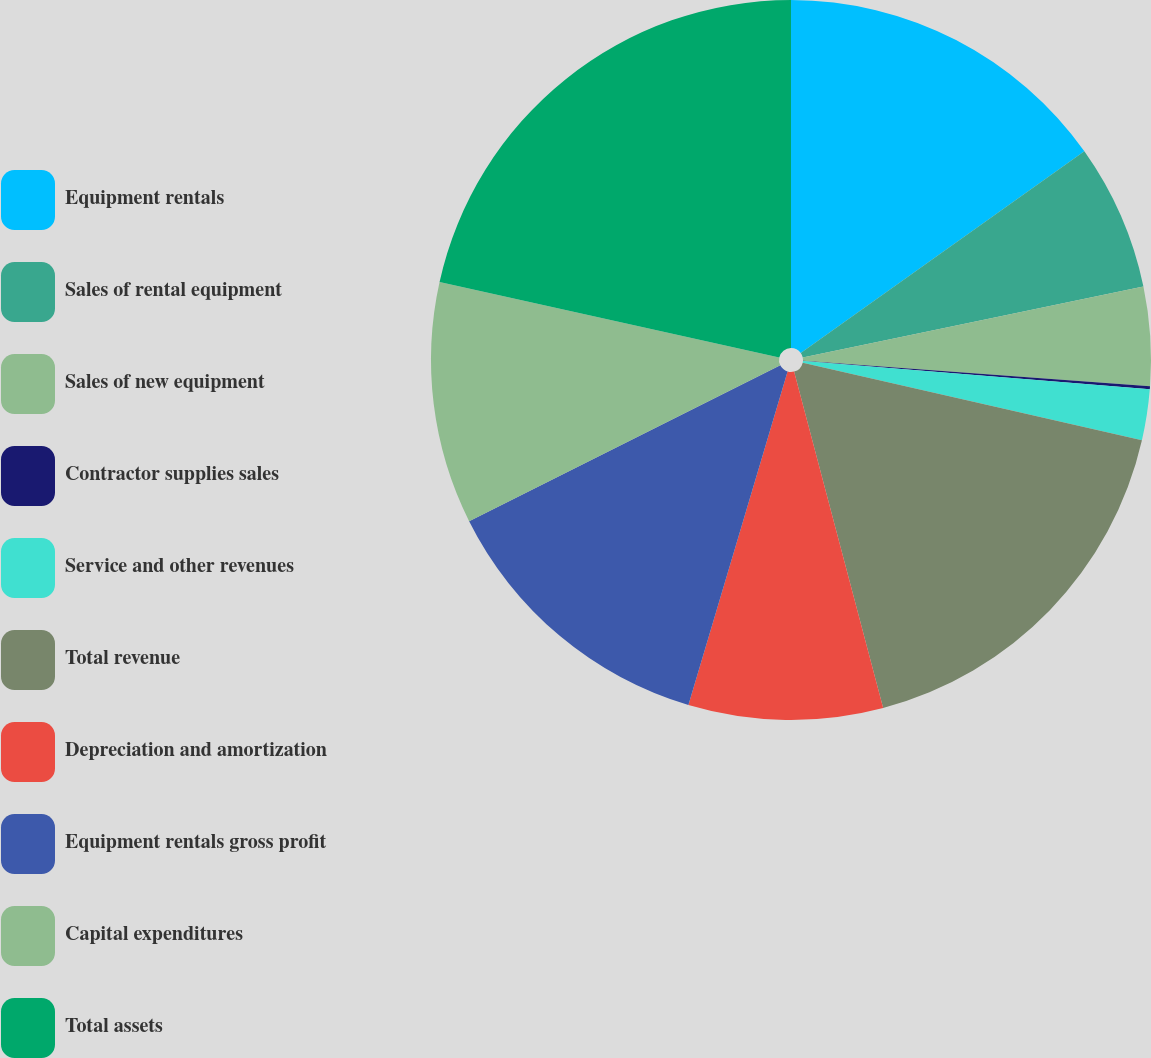Convert chart to OTSL. <chart><loc_0><loc_0><loc_500><loc_500><pie_chart><fcel>Equipment rentals<fcel>Sales of rental equipment<fcel>Sales of new equipment<fcel>Contractor supplies sales<fcel>Service and other revenues<fcel>Total revenue<fcel>Depreciation and amortization<fcel>Equipment rentals gross profit<fcel>Capital expenditures<fcel>Total assets<nl><fcel>15.16%<fcel>6.57%<fcel>4.43%<fcel>0.14%<fcel>2.28%<fcel>17.3%<fcel>8.72%<fcel>13.01%<fcel>10.87%<fcel>21.52%<nl></chart> 